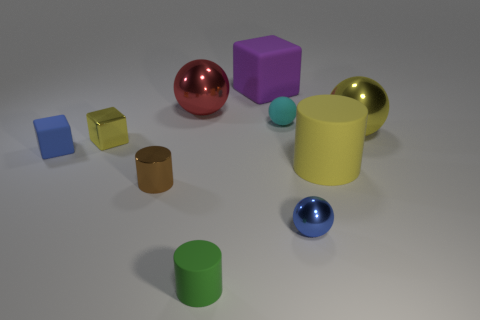What can you infer about the relationship between the objects? They seem to be arranged deliberately to showcase different shapes, sizes, and colors, perhaps as part of an educational display or a visual exploration of geometric forms and their properties. Does this arrangement remind you of anything? It is reminiscent of a study in composition and color theory, where each object plays a role in a larger visual balance, evoking thoughts of an artist's setup or a designer's conceptual model. 